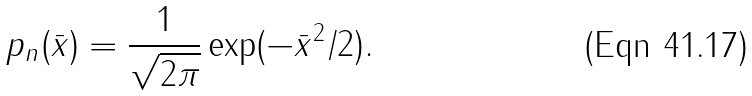<formula> <loc_0><loc_0><loc_500><loc_500>p _ { n } ( \bar { x } ) = \frac { 1 } { \sqrt { 2 \pi } } \exp ( - \bar { x } ^ { 2 } / 2 ) .</formula> 